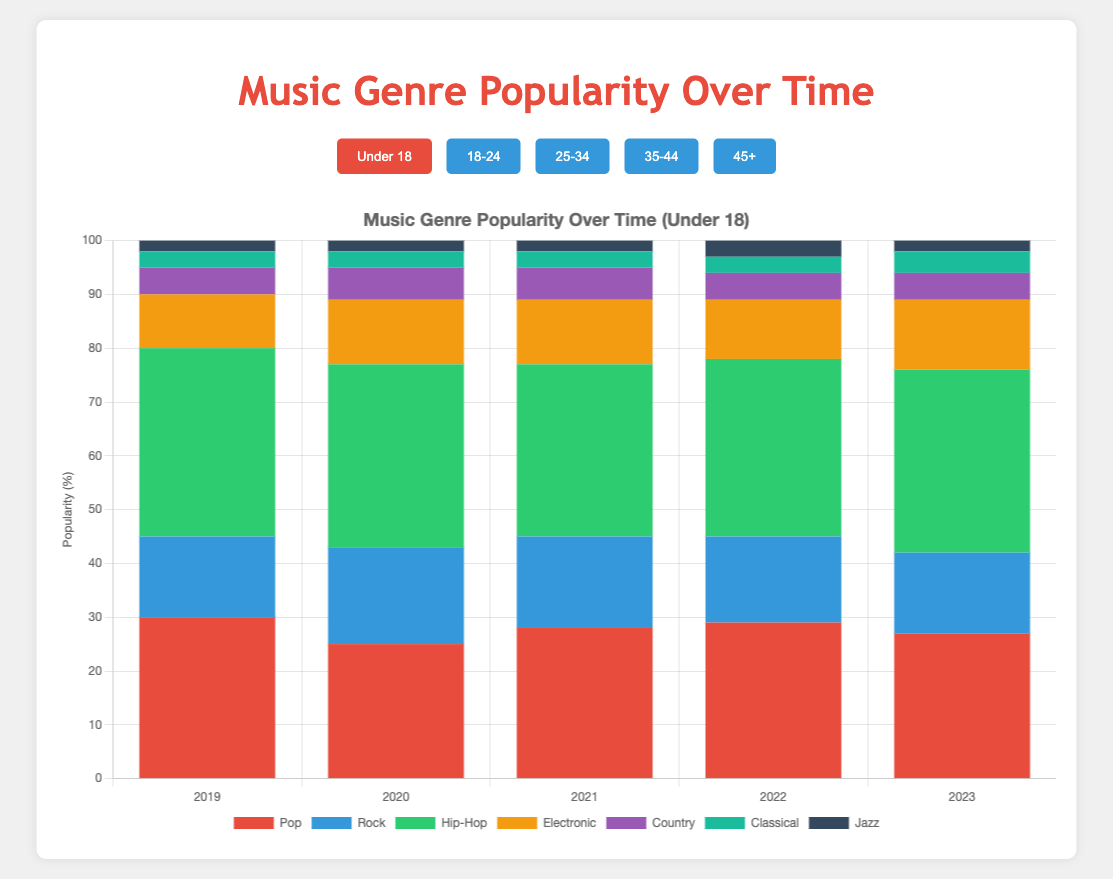How did the popularity of Hip-Hop change for the Under 18 age group from 2019 to 2023? The popularity of Hip-Hop for the Under 18 age group in 2019 was 35%, and in 2023 it was 34%, showing a slight decrease.
Answer: It slightly decreased Which age group experienced the highest increase in the popularity of Electronic music from 2019 to 2023? For the 25-34 age group, the popularity of Electronic music increased from 15% in 2019 to 17% in 2023. For the 45+ age group, the popularity decreased from 8% to 7%. For the 35-44 age group, it went from 12% to 14%. For the 18-24 age group, it went from 15% to 19%. For the under 18 group, it went from 10% to 13%. Therefore, the 18-24 age group experienced the highest increase.
Answer: 18-24 Which genre saw the highest increase in popularity among the 35-44 age group between 2019 and 2023? For the 35-44 age group: Pop from 18% to 20% (+2%), Rock from 30% to 29% (-1%), Hip-Hop from 20% to 23% (+3%), Electronic from 12% to 14% (+2%), Country from 10% to 10% (0%), Classical from 5% to 5% (0%), Jazz from 5% to 4% (-1%). Hip-Hop shows the highest increase of 3%.
Answer: Hip-Hop Compare the popularity of Pop music in 2021 between the 18-24 and the 45+ age groups. In 2021, the popularity of Pop music in the 18-24 age group was 25%, while in the 45+ age group it was 19%. Pop music was more popular in the 18-24 age group than in the 45+ age group.
Answer: 18-24 Which genre was the least popular among ages 45+ in 2023? For the 45+ age group in 2023: Pop: 18%, Rock: 22%, Hip-Hop: 15%, Electronic: 7%, Country: 19%, Classical: 12%, Jazz: 7%. Electronic music has the lowest percentage.
Answer: Electronic What is the average popularity of Rock music over the years 2019-2023 for the age group 25-34? Sum the popularity of Rock music for 2019 to 2023 for the 25-34 age group: 25%, 24%, 22%, 23%, and 22%. The total is 25 + 24 + 22 + 23 + 22 = 116. There are 5 years, so the average is 116 / 5 = 23.2%.
Answer: 23.2% How did the popularity of Classical music change for the under 18 age group from 2019 to 2023? The popularity of Classical music for the under 18 age group remained consistent at 3% from 2019 through 2022 and slightly increased to 4% in 2023.
Answer: Increased by 1% Which genre was consistently the most popular for the 18-24 age group across all years? Observing the data for the 18-24 age group across all years, Hip-Hop was consistently the most popular genre: 2019: 30%, 2020: 28%, 2021: 29%, 2022: 27%, 2023: 26%.
Answer: Hip-Hop 